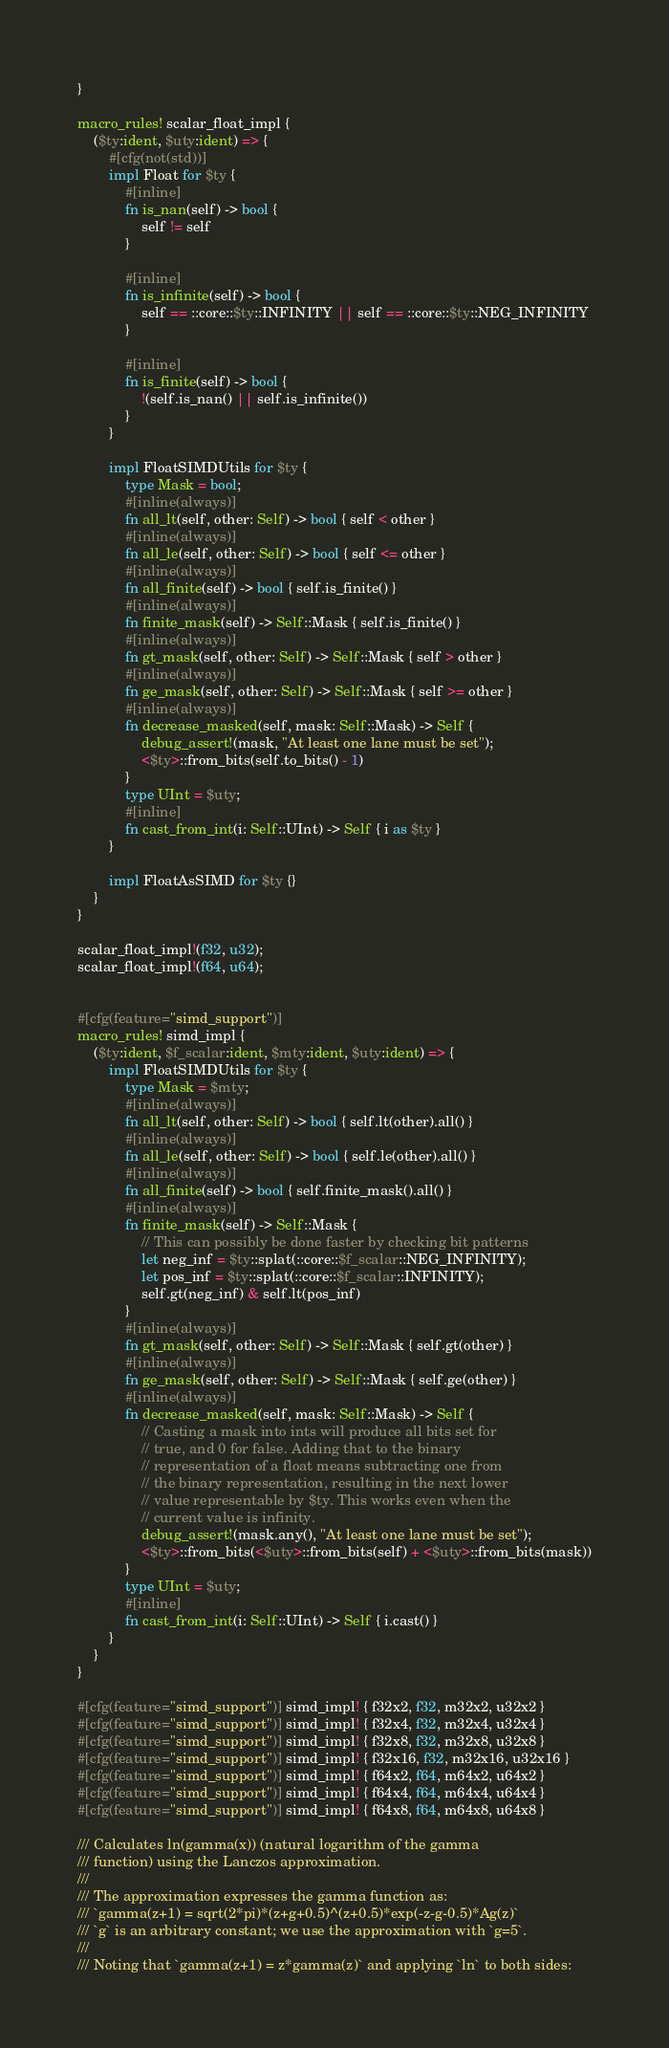<code> <loc_0><loc_0><loc_500><loc_500><_Rust_>}

macro_rules! scalar_float_impl {
    ($ty:ident, $uty:ident) => {
        #[cfg(not(std))]
        impl Float for $ty {
            #[inline]
            fn is_nan(self) -> bool {
                self != self
            }

            #[inline]
            fn is_infinite(self) -> bool {
                self == ::core::$ty::INFINITY || self == ::core::$ty::NEG_INFINITY
            }

            #[inline]
            fn is_finite(self) -> bool {
                !(self.is_nan() || self.is_infinite())
            }
        }

        impl FloatSIMDUtils for $ty {
            type Mask = bool;
            #[inline(always)]
            fn all_lt(self, other: Self) -> bool { self < other }
            #[inline(always)]
            fn all_le(self, other: Self) -> bool { self <= other }
            #[inline(always)]
            fn all_finite(self) -> bool { self.is_finite() }
            #[inline(always)]
            fn finite_mask(self) -> Self::Mask { self.is_finite() }
            #[inline(always)]
            fn gt_mask(self, other: Self) -> Self::Mask { self > other }
            #[inline(always)]
            fn ge_mask(self, other: Self) -> Self::Mask { self >= other }
            #[inline(always)]
            fn decrease_masked(self, mask: Self::Mask) -> Self {
                debug_assert!(mask, "At least one lane must be set");
                <$ty>::from_bits(self.to_bits() - 1)
            }
            type UInt = $uty;
            #[inline]
            fn cast_from_int(i: Self::UInt) -> Self { i as $ty }
        }

        impl FloatAsSIMD for $ty {}
    }
}

scalar_float_impl!(f32, u32);
scalar_float_impl!(f64, u64);


#[cfg(feature="simd_support")]
macro_rules! simd_impl {
    ($ty:ident, $f_scalar:ident, $mty:ident, $uty:ident) => {
        impl FloatSIMDUtils for $ty {
            type Mask = $mty;
            #[inline(always)]
            fn all_lt(self, other: Self) -> bool { self.lt(other).all() }
            #[inline(always)]
            fn all_le(self, other: Self) -> bool { self.le(other).all() }
            #[inline(always)]
            fn all_finite(self) -> bool { self.finite_mask().all() }
            #[inline(always)]
            fn finite_mask(self) -> Self::Mask {
                // This can possibly be done faster by checking bit patterns
                let neg_inf = $ty::splat(::core::$f_scalar::NEG_INFINITY);
                let pos_inf = $ty::splat(::core::$f_scalar::INFINITY);
                self.gt(neg_inf) & self.lt(pos_inf)
            }
            #[inline(always)]
            fn gt_mask(self, other: Self) -> Self::Mask { self.gt(other) }
            #[inline(always)]
            fn ge_mask(self, other: Self) -> Self::Mask { self.ge(other) }
            #[inline(always)]
            fn decrease_masked(self, mask: Self::Mask) -> Self {
                // Casting a mask into ints will produce all bits set for
                // true, and 0 for false. Adding that to the binary
                // representation of a float means subtracting one from
                // the binary representation, resulting in the next lower
                // value representable by $ty. This works even when the
                // current value is infinity.
                debug_assert!(mask.any(), "At least one lane must be set");
                <$ty>::from_bits(<$uty>::from_bits(self) + <$uty>::from_bits(mask))
            }
            type UInt = $uty;
            #[inline]
            fn cast_from_int(i: Self::UInt) -> Self { i.cast() }
        }
    }
}

#[cfg(feature="simd_support")] simd_impl! { f32x2, f32, m32x2, u32x2 }
#[cfg(feature="simd_support")] simd_impl! { f32x4, f32, m32x4, u32x4 }
#[cfg(feature="simd_support")] simd_impl! { f32x8, f32, m32x8, u32x8 }
#[cfg(feature="simd_support")] simd_impl! { f32x16, f32, m32x16, u32x16 }
#[cfg(feature="simd_support")] simd_impl! { f64x2, f64, m64x2, u64x2 }
#[cfg(feature="simd_support")] simd_impl! { f64x4, f64, m64x4, u64x4 }
#[cfg(feature="simd_support")] simd_impl! { f64x8, f64, m64x8, u64x8 }

/// Calculates ln(gamma(x)) (natural logarithm of the gamma
/// function) using the Lanczos approximation.
///
/// The approximation expresses the gamma function as:
/// `gamma(z+1) = sqrt(2*pi)*(z+g+0.5)^(z+0.5)*exp(-z-g-0.5)*Ag(z)`
/// `g` is an arbitrary constant; we use the approximation with `g=5`.
///
/// Noting that `gamma(z+1) = z*gamma(z)` and applying `ln` to both sides:</code> 